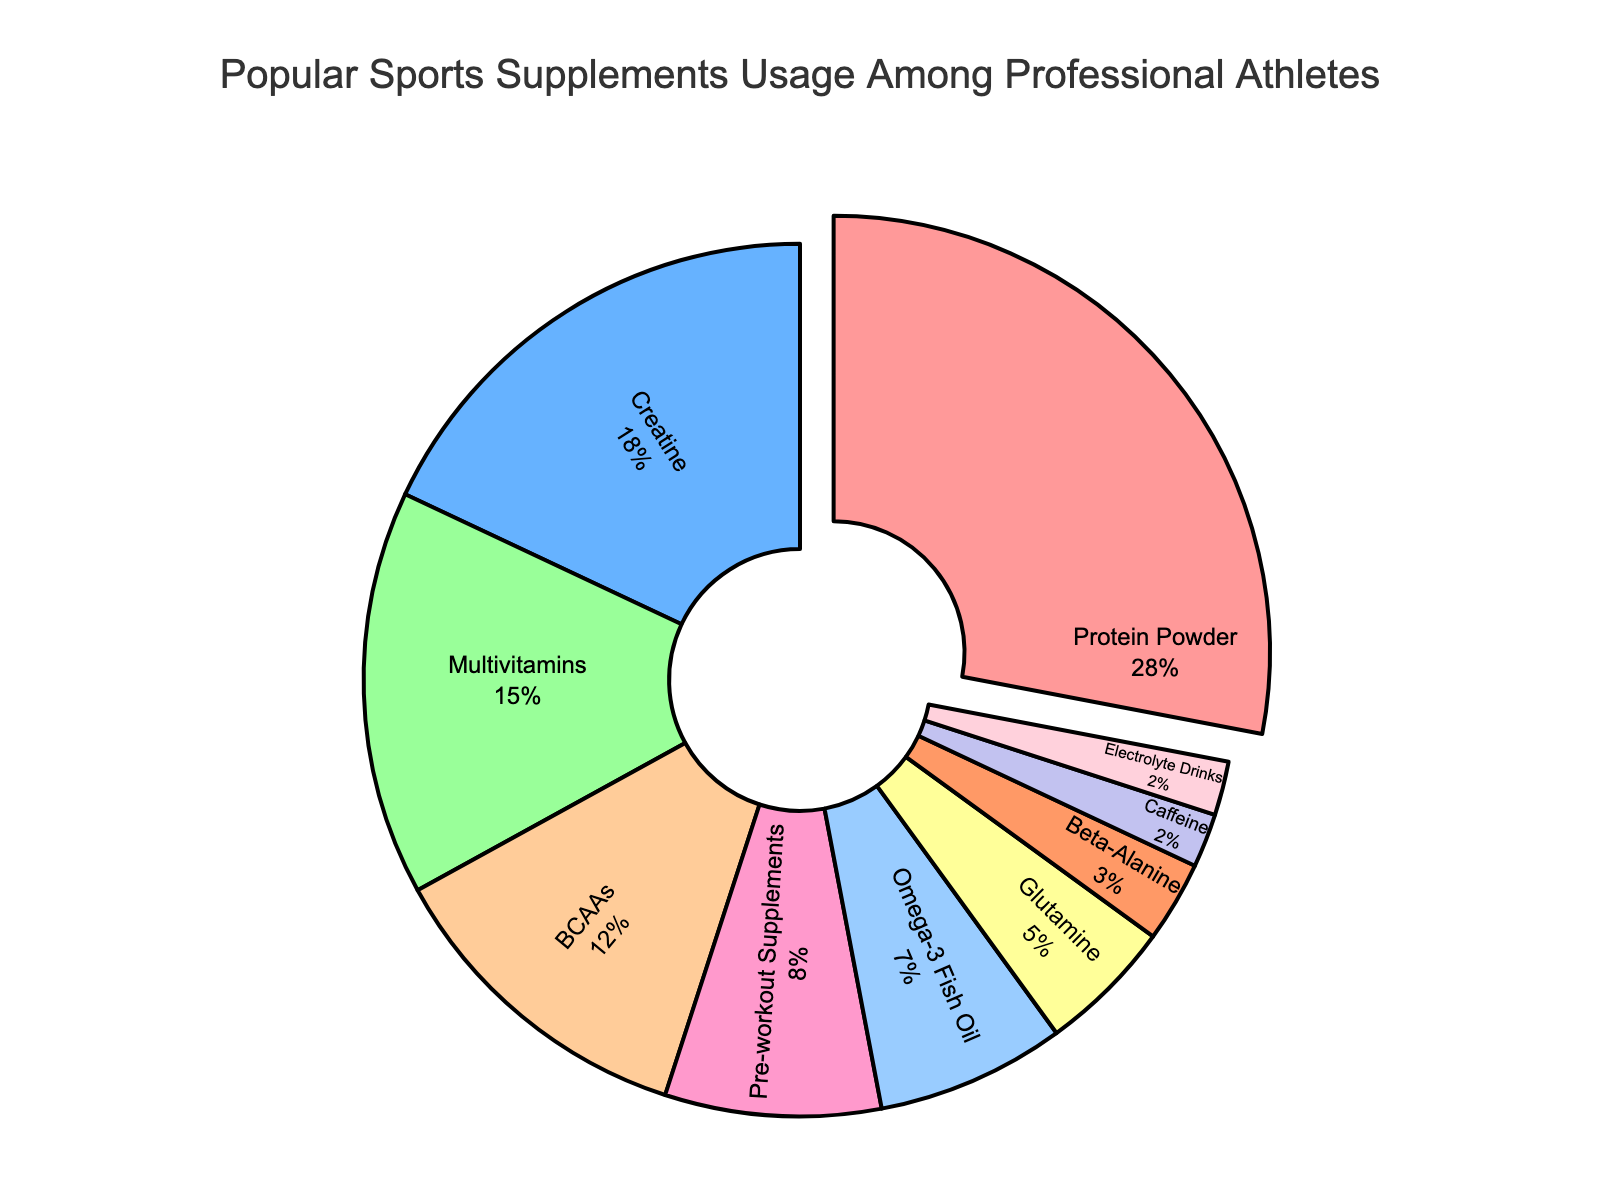What percentage of professional athletes use Protein Powder? The data shows that Protein Powder is used by 28% of professional athletes. Hence, the percentage for Protein Powder is directly visible on the plot.
Answer: 28% Which supplement is used less frequently by professional athletes, Glutamine or Caffeine? According to the pie chart, 5% of professional athletes use Glutamine while 2% use Caffeine. Therefore, Caffeine is used less frequently than Glutamine.
Answer: Caffeine What proportion of professional athletes use either Omega-3 Fish Oil or Multivitamins? The data shows that 7% of athletes use Omega-3 Fish Oil and 15% use Multivitamins. Adding these percentages, 7% + 15%, gives the total proportion.
Answer: 22% Which supplement has the second-highest usage among professional athletes? From the pie chart, the supplement with the highest usage is Protein Powder at 28%. The next highest percentage is 18%, which corresponds to Creatine.
Answer: Creatine Are there any supplements that have the same percentage of usage among professional athletes, and if so, which ones? By observing the percentages on the pie chart, Caffeine and Electrolyte Drinks both show a usage rate of 2%.
Answer: Caffeine and Electrolyte Drinks What is the combined percentage of professional athletes using pre-workout supplements and BCAAs? The chart shows that 8% of athletes use pre-workout supplements, and 12% use BCAAs. Summing these gives 8% + 12% = 20%.
Answer: 20% How much more popular is Protein Powder compared to Beta-Alanine among professional athletes? The usage of Protein Powder is 28%, and Beta-Alanine is 3%. The difference is 28% - 3%.
Answer: 25% How many supplements have a usage rate of less than 10% among professional athletes? By looking at the pie chart, Pre-workout Supplements (8%), Omega-3 Fish Oil (7%), Glutamine (5%), Beta-Alanine (3%), Caffeine (2%), and Electrolyte Drinks (2%) all have usage rates less than 10%. Counting these, we get a total of 6 supplements.
Answer: 6 Which supplement has a higher usage rate, BCAAs or Multivitamins? According to the chart, BCAAs have a usage rate of 12%, and Multivitamins have a usage rate of 15%. Thus, Multivitamins have a higher usage rate.
Answer: Multivitamins What is the combined percentage of professional athletes using Protein Powder, Creatine, and Multivitamins? Protein Powder usage is 28%, Creatine is 18%, and Multivitamins are 15%. Adding these together gives 28% + 18% + 15% = 61%.
Answer: 61% 